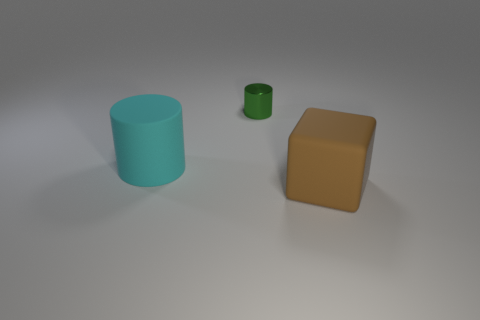The large rubber thing that is behind the rubber object that is on the right side of the green metal object is what color?
Offer a terse response. Cyan. What number of tiny things are there?
Keep it short and to the point. 1. How many big objects are to the left of the tiny green cylinder and in front of the big matte cylinder?
Provide a succinct answer. 0. Is there any other thing that is the same shape as the big brown thing?
Keep it short and to the point. No. The matte object to the left of the brown object has what shape?
Your answer should be compact. Cylinder. How many other objects are there of the same material as the big cyan object?
Your answer should be compact. 1. What material is the big cyan cylinder?
Your answer should be compact. Rubber. How many large objects are either green things or gray rubber cylinders?
Give a very brief answer. 0. How many matte cubes are left of the tiny green thing?
Ensure brevity in your answer.  0. Is there a large cylinder of the same color as the tiny cylinder?
Provide a short and direct response. No. 